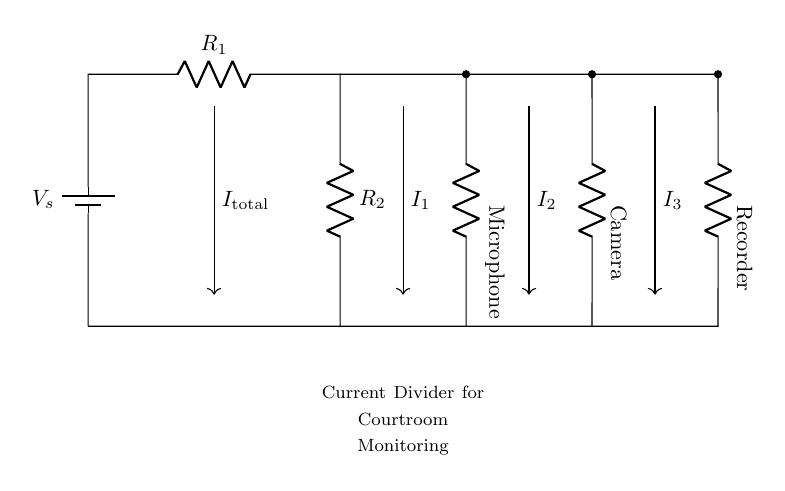What is the source voltage in this circuit? The source voltage is denoted as V_s, which represents the voltage provided by the battery. It is the potential difference across the points where the battery is connected.
Answer: V_s How many load components are present in the circuit? There are three load components connected to the current divider: a microphone, a camera, and a recorder. Each of these components is placed in parallel, reflecting the current division principle.
Answer: Three What type of circuit is represented? The circuit displayed is a current divider because it divides the total current into multiple paths through the parallel resistive loads connected to the source.
Answer: Current divider What is the relationship between total current and individual branch currents? The total current (I_total) entering the circuit is equal to the sum of the individual branch currents (I_1, I_2, and I_3) flowing through the microphone, camera, and recorder due to the current division rule.
Answer: I_total = I_1 + I_2 + I_3 What happens to the currents when resistance values change? If the resistance values of individual branches (R_1, R_2, etc.) change, the current through each branch will inversely change according to Ohm's law and the principle of current division, affecting the division of total current among the loads.
Answer: Inversely proportional What is the function of the resistor labeled R_1? The resistor R_1 acts as one of the branches in the circuit, helping to determine the amount of current that divides into the parallel loads. Its value directly influences the current distribution among the microphone, camera, and recorder.
Answer: Current divider branch 